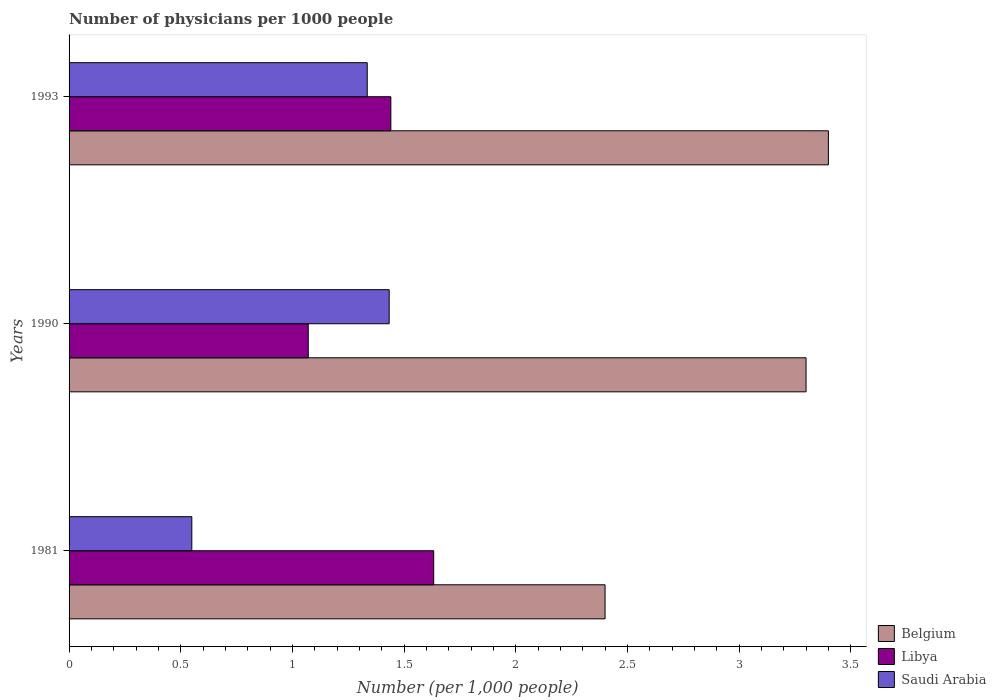How many different coloured bars are there?
Ensure brevity in your answer.  3. How many groups of bars are there?
Your answer should be compact. 3. How many bars are there on the 1st tick from the top?
Your answer should be compact. 3. How many bars are there on the 2nd tick from the bottom?
Keep it short and to the point. 3. What is the label of the 2nd group of bars from the top?
Your response must be concise. 1990. In how many cases, is the number of bars for a given year not equal to the number of legend labels?
Provide a short and direct response. 0. What is the number of physicians in Libya in 1993?
Offer a terse response. 1.44. Across all years, what is the maximum number of physicians in Saudi Arabia?
Your response must be concise. 1.43. Across all years, what is the minimum number of physicians in Belgium?
Provide a short and direct response. 2.4. In which year was the number of physicians in Saudi Arabia minimum?
Offer a terse response. 1981. What is the difference between the number of physicians in Libya in 1990 and that in 1993?
Your answer should be very brief. -0.37. What is the difference between the number of physicians in Libya in 1990 and the number of physicians in Saudi Arabia in 1993?
Keep it short and to the point. -0.26. What is the average number of physicians in Belgium per year?
Your answer should be very brief. 3.03. In the year 1981, what is the difference between the number of physicians in Belgium and number of physicians in Libya?
Your answer should be compact. 0.77. What is the ratio of the number of physicians in Saudi Arabia in 1990 to that in 1993?
Make the answer very short. 1.07. Is the number of physicians in Saudi Arabia in 1981 less than that in 1993?
Offer a terse response. Yes. What is the difference between the highest and the second highest number of physicians in Libya?
Your answer should be compact. 0.19. What is the difference between the highest and the lowest number of physicians in Libya?
Give a very brief answer. 0.56. What does the 3rd bar from the top in 1981 represents?
Ensure brevity in your answer.  Belgium. What does the 3rd bar from the bottom in 1981 represents?
Make the answer very short. Saudi Arabia. How many years are there in the graph?
Provide a short and direct response. 3. Are the values on the major ticks of X-axis written in scientific E-notation?
Offer a terse response. No. Where does the legend appear in the graph?
Your response must be concise. Bottom right. How are the legend labels stacked?
Provide a short and direct response. Vertical. What is the title of the graph?
Keep it short and to the point. Number of physicians per 1000 people. Does "Middle income" appear as one of the legend labels in the graph?
Ensure brevity in your answer.  No. What is the label or title of the X-axis?
Offer a terse response. Number (per 1,0 people). What is the Number (per 1,000 people) of Libya in 1981?
Your response must be concise. 1.63. What is the Number (per 1,000 people) in Saudi Arabia in 1981?
Your answer should be very brief. 0.55. What is the Number (per 1,000 people) in Libya in 1990?
Your response must be concise. 1.07. What is the Number (per 1,000 people) in Saudi Arabia in 1990?
Your response must be concise. 1.43. What is the Number (per 1,000 people) in Belgium in 1993?
Your response must be concise. 3.4. What is the Number (per 1,000 people) in Libya in 1993?
Offer a very short reply. 1.44. What is the Number (per 1,000 people) in Saudi Arabia in 1993?
Keep it short and to the point. 1.34. Across all years, what is the maximum Number (per 1,000 people) of Libya?
Keep it short and to the point. 1.63. Across all years, what is the maximum Number (per 1,000 people) in Saudi Arabia?
Offer a very short reply. 1.43. Across all years, what is the minimum Number (per 1,000 people) in Belgium?
Keep it short and to the point. 2.4. Across all years, what is the minimum Number (per 1,000 people) of Libya?
Your response must be concise. 1.07. Across all years, what is the minimum Number (per 1,000 people) in Saudi Arabia?
Make the answer very short. 0.55. What is the total Number (per 1,000 people) of Libya in the graph?
Make the answer very short. 4.14. What is the total Number (per 1,000 people) of Saudi Arabia in the graph?
Make the answer very short. 3.32. What is the difference between the Number (per 1,000 people) of Libya in 1981 and that in 1990?
Your answer should be compact. 0.56. What is the difference between the Number (per 1,000 people) in Saudi Arabia in 1981 and that in 1990?
Offer a very short reply. -0.88. What is the difference between the Number (per 1,000 people) in Libya in 1981 and that in 1993?
Your response must be concise. 0.19. What is the difference between the Number (per 1,000 people) of Saudi Arabia in 1981 and that in 1993?
Provide a short and direct response. -0.79. What is the difference between the Number (per 1,000 people) of Belgium in 1990 and that in 1993?
Keep it short and to the point. -0.1. What is the difference between the Number (per 1,000 people) of Libya in 1990 and that in 1993?
Make the answer very short. -0.37. What is the difference between the Number (per 1,000 people) of Saudi Arabia in 1990 and that in 1993?
Provide a succinct answer. 0.1. What is the difference between the Number (per 1,000 people) of Belgium in 1981 and the Number (per 1,000 people) of Libya in 1990?
Offer a very short reply. 1.33. What is the difference between the Number (per 1,000 people) in Belgium in 1981 and the Number (per 1,000 people) in Saudi Arabia in 1990?
Offer a terse response. 0.97. What is the difference between the Number (per 1,000 people) of Libya in 1981 and the Number (per 1,000 people) of Saudi Arabia in 1990?
Keep it short and to the point. 0.2. What is the difference between the Number (per 1,000 people) of Belgium in 1981 and the Number (per 1,000 people) of Libya in 1993?
Your response must be concise. 0.96. What is the difference between the Number (per 1,000 people) of Belgium in 1981 and the Number (per 1,000 people) of Saudi Arabia in 1993?
Offer a terse response. 1.06. What is the difference between the Number (per 1,000 people) in Libya in 1981 and the Number (per 1,000 people) in Saudi Arabia in 1993?
Your answer should be compact. 0.3. What is the difference between the Number (per 1,000 people) of Belgium in 1990 and the Number (per 1,000 people) of Libya in 1993?
Offer a very short reply. 1.86. What is the difference between the Number (per 1,000 people) of Belgium in 1990 and the Number (per 1,000 people) of Saudi Arabia in 1993?
Give a very brief answer. 1.96. What is the difference between the Number (per 1,000 people) in Libya in 1990 and the Number (per 1,000 people) in Saudi Arabia in 1993?
Your response must be concise. -0.26. What is the average Number (per 1,000 people) in Belgium per year?
Make the answer very short. 3.03. What is the average Number (per 1,000 people) in Libya per year?
Ensure brevity in your answer.  1.38. What is the average Number (per 1,000 people) of Saudi Arabia per year?
Provide a short and direct response. 1.11. In the year 1981, what is the difference between the Number (per 1,000 people) in Belgium and Number (per 1,000 people) in Libya?
Ensure brevity in your answer.  0.77. In the year 1981, what is the difference between the Number (per 1,000 people) in Belgium and Number (per 1,000 people) in Saudi Arabia?
Keep it short and to the point. 1.85. In the year 1981, what is the difference between the Number (per 1,000 people) in Libya and Number (per 1,000 people) in Saudi Arabia?
Your answer should be very brief. 1.08. In the year 1990, what is the difference between the Number (per 1,000 people) in Belgium and Number (per 1,000 people) in Libya?
Make the answer very short. 2.23. In the year 1990, what is the difference between the Number (per 1,000 people) of Belgium and Number (per 1,000 people) of Saudi Arabia?
Provide a succinct answer. 1.87. In the year 1990, what is the difference between the Number (per 1,000 people) in Libya and Number (per 1,000 people) in Saudi Arabia?
Ensure brevity in your answer.  -0.36. In the year 1993, what is the difference between the Number (per 1,000 people) of Belgium and Number (per 1,000 people) of Libya?
Your answer should be very brief. 1.96. In the year 1993, what is the difference between the Number (per 1,000 people) in Belgium and Number (per 1,000 people) in Saudi Arabia?
Provide a succinct answer. 2.06. In the year 1993, what is the difference between the Number (per 1,000 people) in Libya and Number (per 1,000 people) in Saudi Arabia?
Offer a terse response. 0.11. What is the ratio of the Number (per 1,000 people) in Belgium in 1981 to that in 1990?
Your answer should be very brief. 0.73. What is the ratio of the Number (per 1,000 people) of Libya in 1981 to that in 1990?
Your response must be concise. 1.52. What is the ratio of the Number (per 1,000 people) of Saudi Arabia in 1981 to that in 1990?
Your answer should be very brief. 0.38. What is the ratio of the Number (per 1,000 people) in Belgium in 1981 to that in 1993?
Provide a short and direct response. 0.71. What is the ratio of the Number (per 1,000 people) of Libya in 1981 to that in 1993?
Make the answer very short. 1.13. What is the ratio of the Number (per 1,000 people) in Saudi Arabia in 1981 to that in 1993?
Make the answer very short. 0.41. What is the ratio of the Number (per 1,000 people) of Belgium in 1990 to that in 1993?
Provide a succinct answer. 0.97. What is the ratio of the Number (per 1,000 people) in Libya in 1990 to that in 1993?
Offer a terse response. 0.74. What is the ratio of the Number (per 1,000 people) of Saudi Arabia in 1990 to that in 1993?
Provide a succinct answer. 1.07. What is the difference between the highest and the second highest Number (per 1,000 people) in Libya?
Make the answer very short. 0.19. What is the difference between the highest and the second highest Number (per 1,000 people) of Saudi Arabia?
Keep it short and to the point. 0.1. What is the difference between the highest and the lowest Number (per 1,000 people) in Belgium?
Provide a short and direct response. 1. What is the difference between the highest and the lowest Number (per 1,000 people) of Libya?
Give a very brief answer. 0.56. What is the difference between the highest and the lowest Number (per 1,000 people) in Saudi Arabia?
Ensure brevity in your answer.  0.88. 